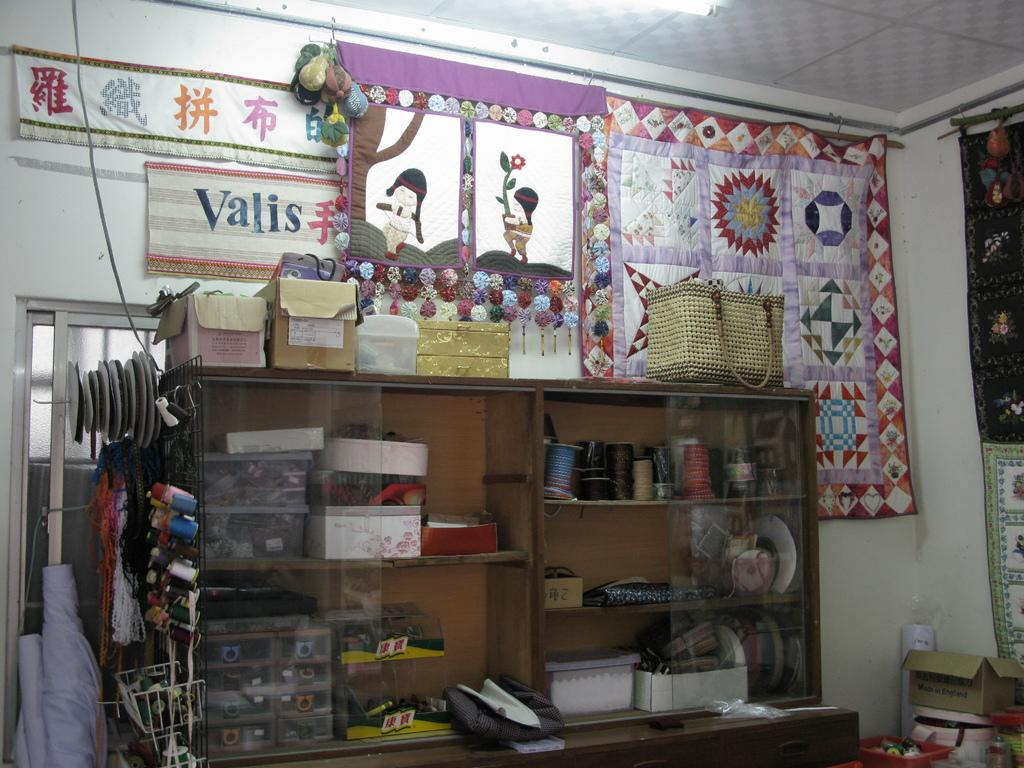<image>
Render a clear and concise summary of the photo. A habidashery shop has many items and the name Valis on the wall. 